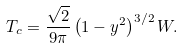<formula> <loc_0><loc_0><loc_500><loc_500>T _ { c } = \frac { \sqrt { 2 } } { 9 \pi } \left ( 1 - y ^ { 2 } \right ) ^ { 3 / 2 } W .</formula> 